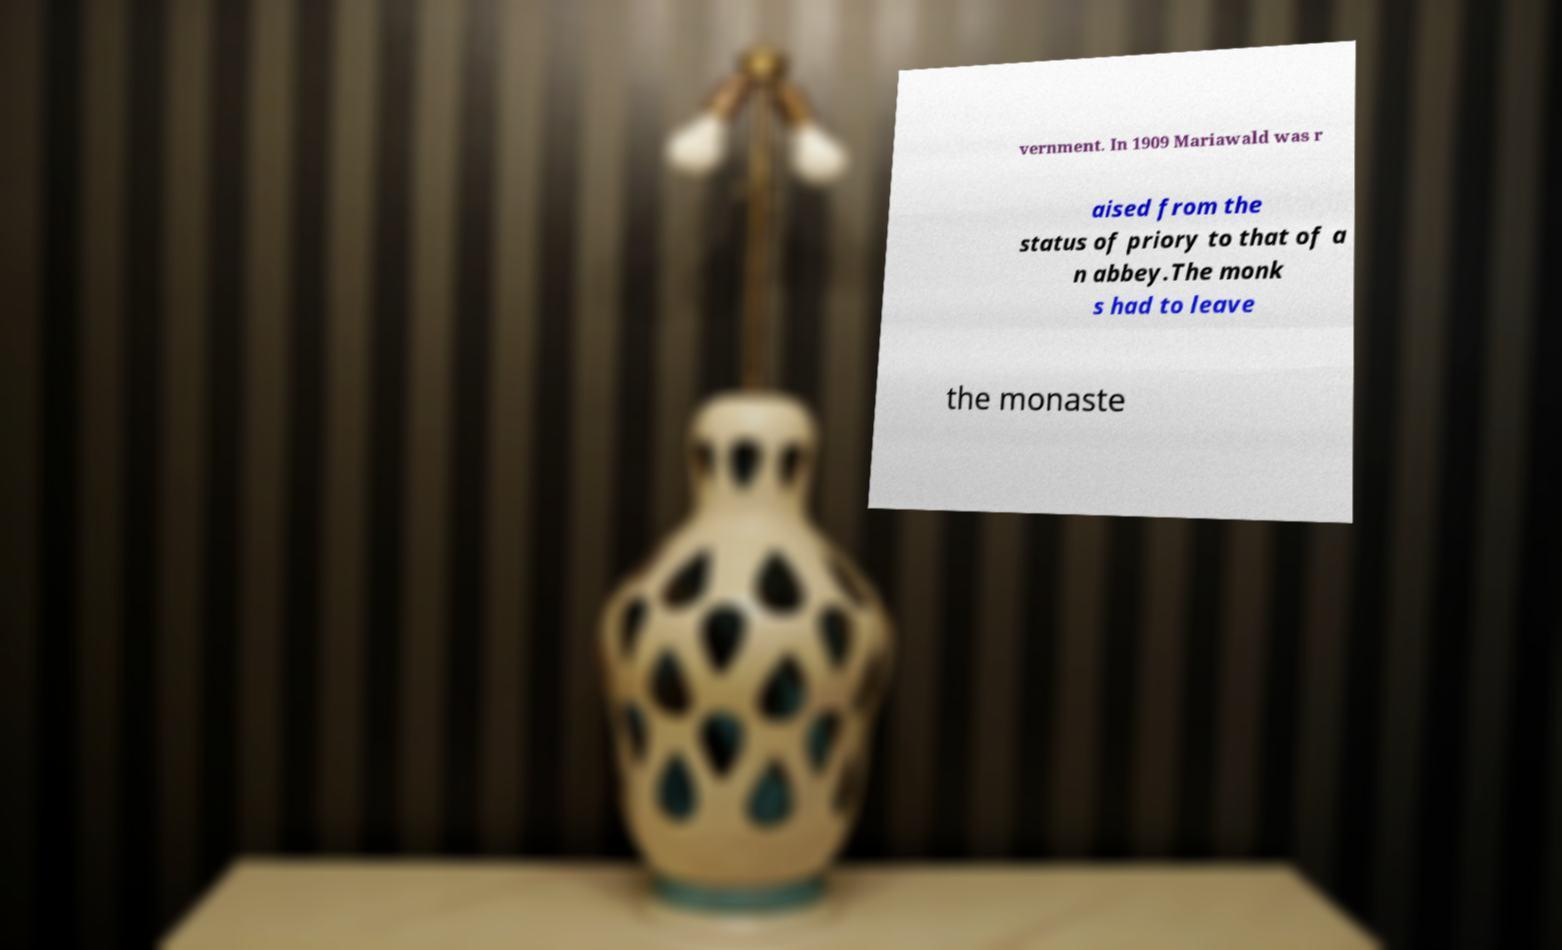There's text embedded in this image that I need extracted. Can you transcribe it verbatim? vernment. In 1909 Mariawald was r aised from the status of priory to that of a n abbey.The monk s had to leave the monaste 